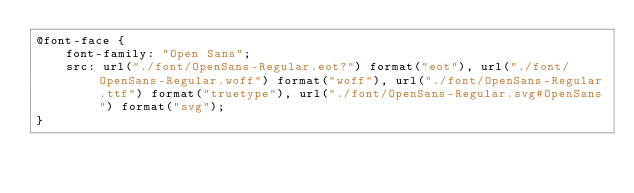Convert code to text. <code><loc_0><loc_0><loc_500><loc_500><_CSS_>@font-face {
    font-family: "Open Sans";
    src: url("./font/OpenSans-Regular.eot?") format("eot"), url("./font/OpenSans-Regular.woff") format("woff"), url("./font/OpenSans-Regular.ttf") format("truetype"), url("./font/OpenSans-Regular.svg#OpenSans") format("svg");
}
</code> 